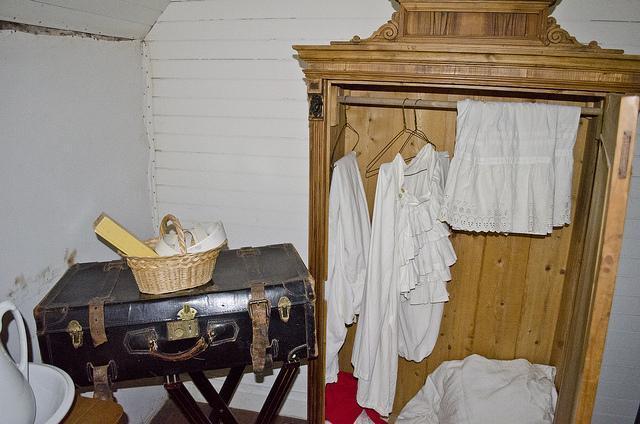How many white shirts?
Give a very brief answer. 2. 